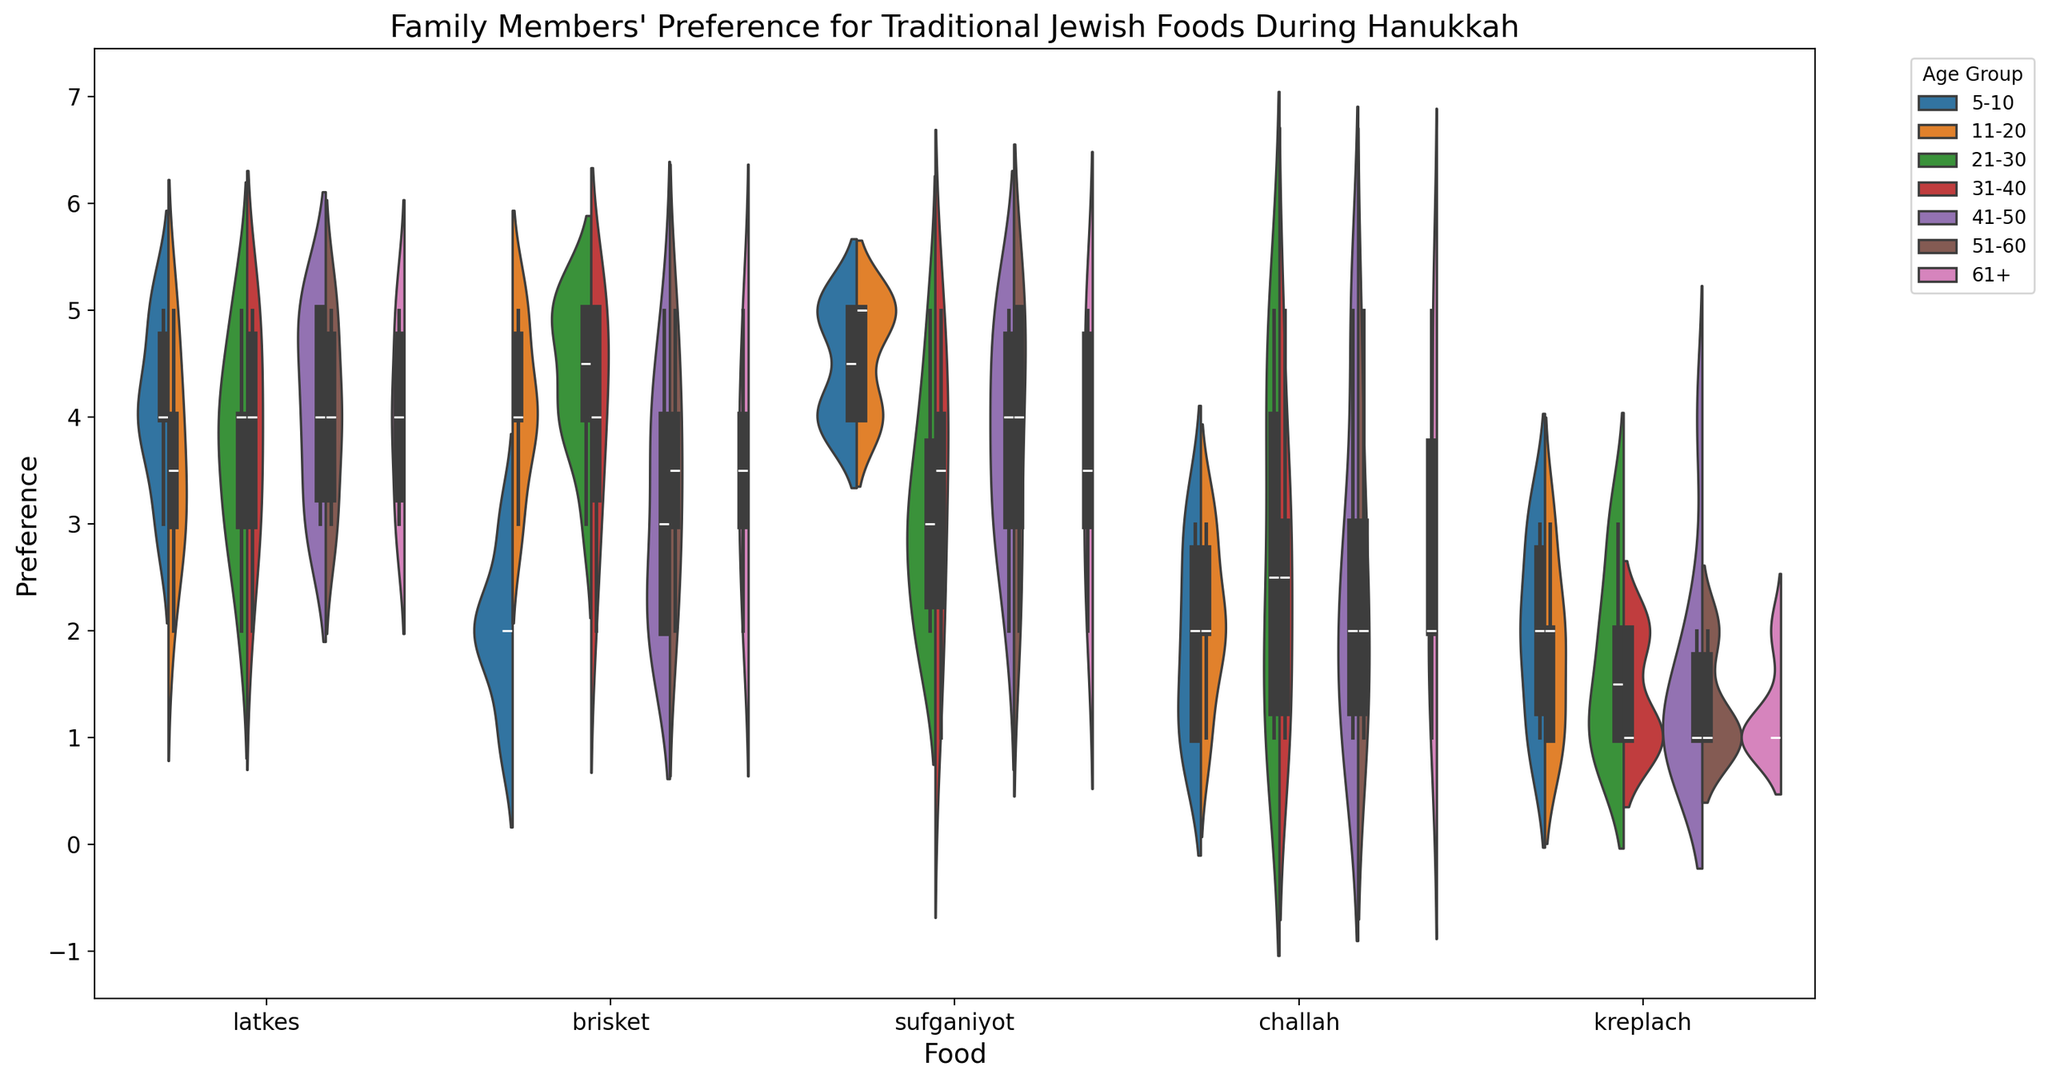What age group has the highest preference for latkes? Look at the violin plot for latkes and compare the height and spread for each age group. The group with the highest median value and wider spread towards higher values has the highest preference.
Answer: 21-30 Do older age groups prefer brisket more than younger age groups? Compare the brisket preference across age groups by examining the height and median values. Focus on the groups 51-60 and 61+ versus groups 5-10 and 11-20.
Answer: Yes What's the highest preference score recorded for sufganiyot across all age groups? Identify the maximum value in the sufganiyot section of the violin plot, which indicates the highest preference score.
Answer: 5 Which food shows the least variation in preference among 31-40 year olds? Examine the width of the violins for each food within the 31-40 group; the narrower the violin, the less variation there is.
Answer: Brisket Do younger children (5-10 years) and older adults (61+) have similar preferences for challah? Compare the medians and distributions of challah preference for the age groups 5-10 and 61+.
Answer: No Which age group has the most varied preferences for kreplach? Determine which age group has the widest and most spread-out violin for kreplach, indicating high variation.
Answer: 5-10 Do all age groups prefer sufganiyot more than challah? For each age group, compare the heights and medians of the sufganiyot and challah violins. Check if sufganiyot is generally preferred more.
Answer: Yes Is the median preference for latkes higher than the median preference for brisket across all age groups? For each age group, compare the median values represented on the violins for latkes and brisket.
Answer: No Which food does the age group 21-30 prefer the least? Identify the food with the lowest median value and narrowest spread in the 21-30 age group.
Answer: Kreplach Which two age groups have the closest median preferences for sufganiyot? Look for the age groups whose median lines for sufganiyot are at the same or very similar levels.
Answer: 11-20 and 31-40 